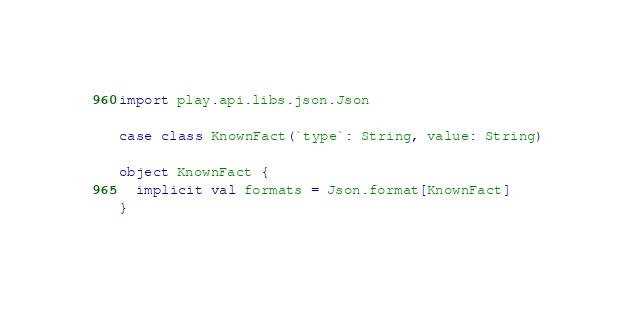<code> <loc_0><loc_0><loc_500><loc_500><_Scala_>import play.api.libs.json.Json

case class KnownFact(`type`: String, value: String)

object KnownFact {
  implicit val formats = Json.format[KnownFact]
}

</code> 